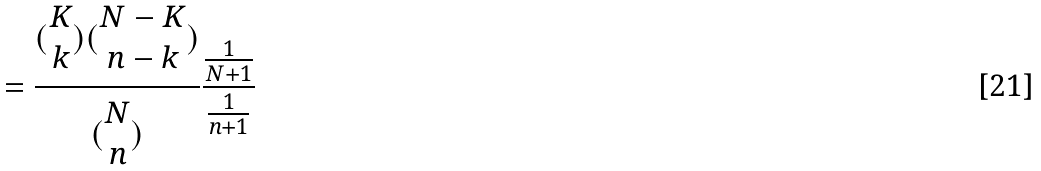<formula> <loc_0><loc_0><loc_500><loc_500>= \frac { ( \begin{matrix} K \\ k \end{matrix} ) ( \begin{matrix} N - K \\ n - k \end{matrix} ) } { ( \begin{matrix} N \\ n \end{matrix} ) } \frac { \frac { 1 } { N + 1 } } { \frac { 1 } { n + 1 } }</formula> 